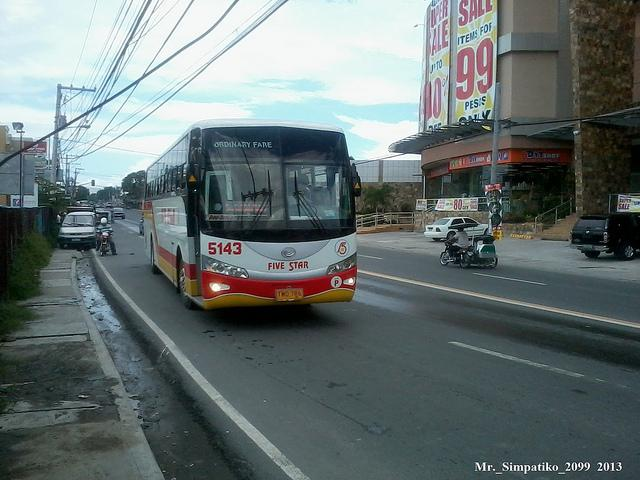What type of sign is on the building?

Choices:
A) informational
B) directional
C) warning
D) brand informational 